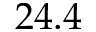<formula> <loc_0><loc_0><loc_500><loc_500>2 4 . 4</formula> 